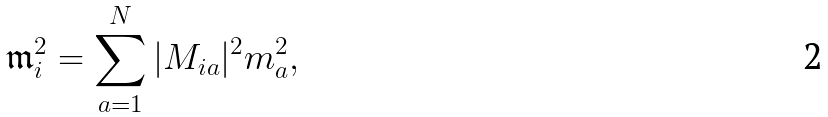<formula> <loc_0><loc_0><loc_500><loc_500>\mathfrak { m } _ { i } ^ { 2 } = \sum _ { a = 1 } ^ { N } | M _ { i a } | ^ { 2 } m _ { a } ^ { 2 } ,</formula> 